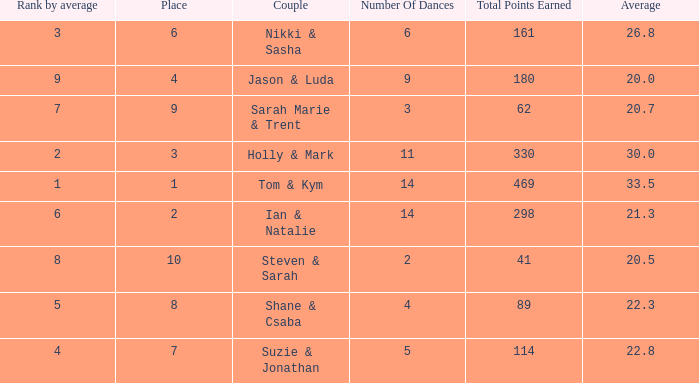Give me the full table as a dictionary. {'header': ['Rank by average', 'Place', 'Couple', 'Number Of Dances', 'Total Points Earned', 'Average'], 'rows': [['3', '6', 'Nikki & Sasha', '6', '161', '26.8'], ['9', '4', 'Jason & Luda', '9', '180', '20.0'], ['7', '9', 'Sarah Marie & Trent', '3', '62', '20.7'], ['2', '3', 'Holly & Mark', '11', '330', '30.0'], ['1', '1', 'Tom & Kym', '14', '469', '33.5'], ['6', '2', 'Ian & Natalie', '14', '298', '21.3'], ['8', '10', 'Steven & Sarah', '2', '41', '20.5'], ['5', '8', 'Shane & Csaba', '4', '89', '22.3'], ['4', '7', 'Suzie & Jonathan', '5', '114', '22.8']]} What is the name of the couple if the total points earned is 161? Nikki & Sasha. 